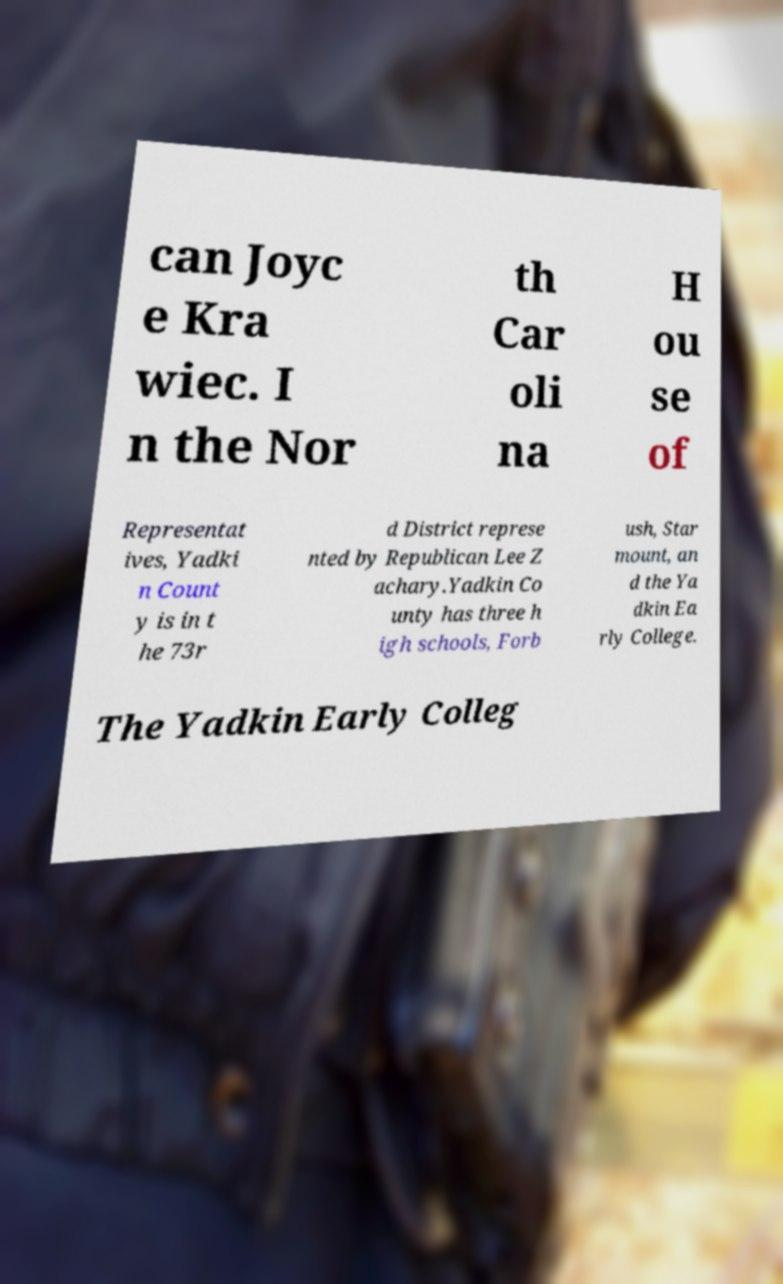Please identify and transcribe the text found in this image. can Joyc e Kra wiec. I n the Nor th Car oli na H ou se of Representat ives, Yadki n Count y is in t he 73r d District represe nted by Republican Lee Z achary.Yadkin Co unty has three h igh schools, Forb ush, Star mount, an d the Ya dkin Ea rly College. The Yadkin Early Colleg 